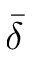Convert formula to latex. <formula><loc_0><loc_0><loc_500><loc_500>\bar { \delta }</formula> 